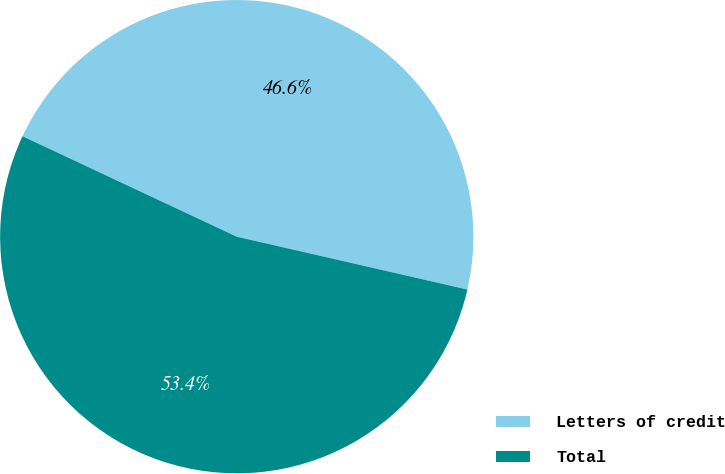Convert chart. <chart><loc_0><loc_0><loc_500><loc_500><pie_chart><fcel>Letters of credit<fcel>Total<nl><fcel>46.61%<fcel>53.39%<nl></chart> 